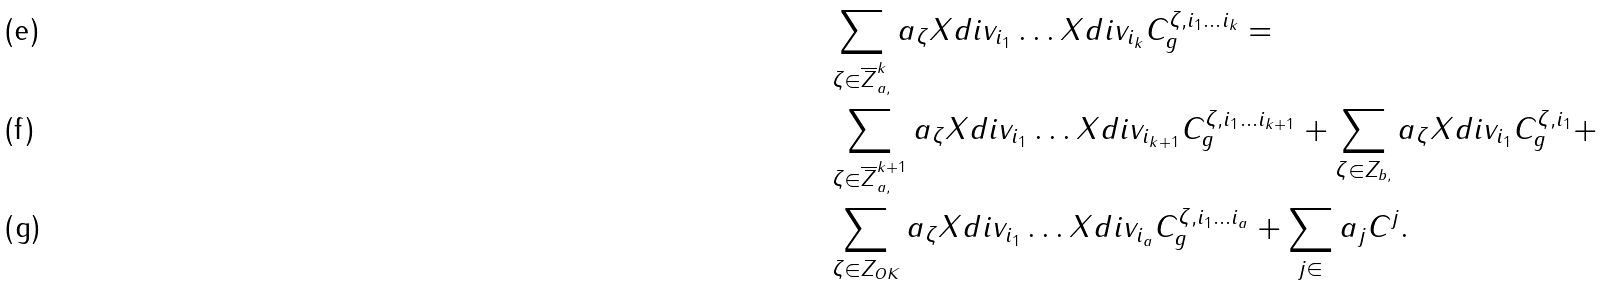<formula> <loc_0><loc_0><loc_500><loc_500>& \sum _ { \zeta \in \overline { Z } _ { a , } ^ { k } } a _ { \zeta } X d i v _ { i _ { 1 } } \dots X d i v _ { i _ { k } } C ^ { \zeta , i _ { 1 } \dots i _ { k } } _ { g } = \\ & \sum _ { \zeta \in \overline { Z } _ { a , } ^ { k + 1 } } a _ { \zeta } X d i v _ { i _ { 1 } } \dots X d i v _ { i _ { k + 1 } } C ^ { \zeta , i _ { 1 } \dots i _ { k + 1 } } _ { g } + \sum _ { \zeta \in Z _ { b , } } a _ { \zeta } X d i v _ { i _ { 1 } } C ^ { \zeta , i _ { 1 } } _ { g } + \\ & \sum _ { \zeta \in Z _ { O K } } a _ { \zeta } X d i v _ { i _ { 1 } } \dots X d i v _ { i _ { a } } C ^ { \zeta , i _ { 1 } \dots i _ { a } } _ { g } + \sum _ { j \in } a _ { j } C ^ { j } .</formula> 